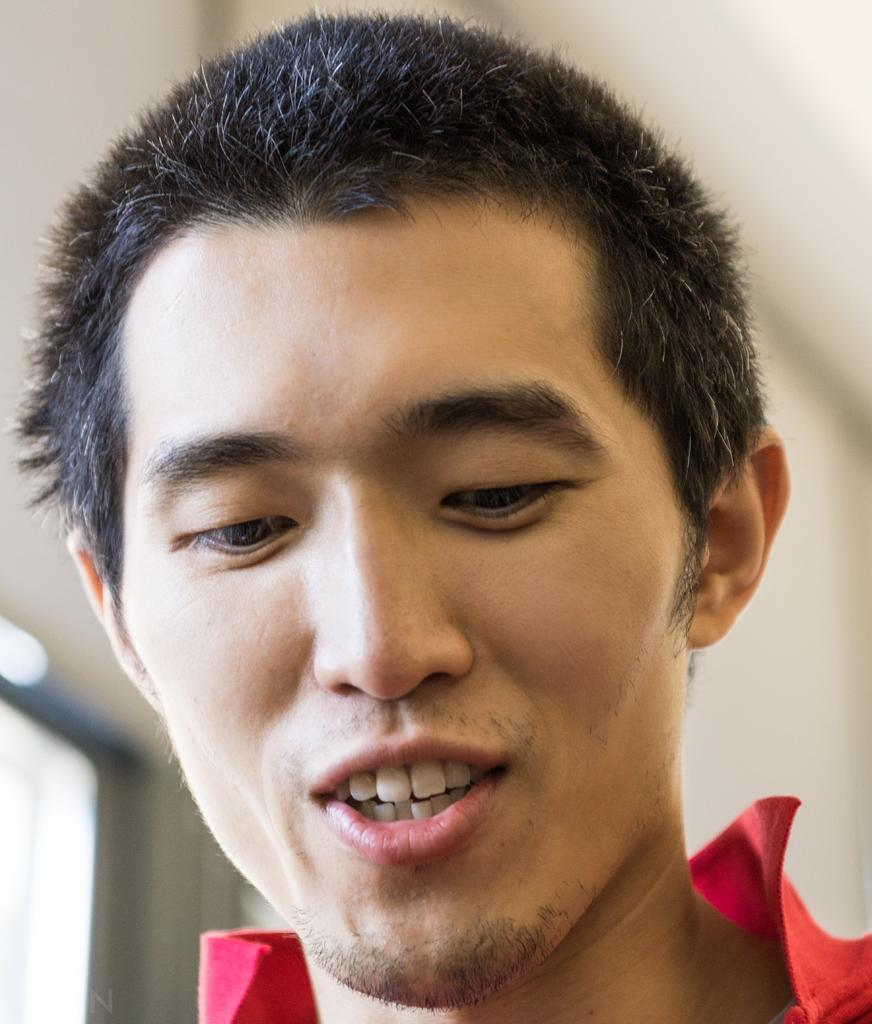Who is present in the image? There is a man in the image. Can you describe the background of the image? The background of the image is blurred. How many flags are visible in the image? There are no flags present in the image. Are there any spiders crawling on the man in the image? There is no mention of spiders in the image, and therefore no such activity can be observed. 